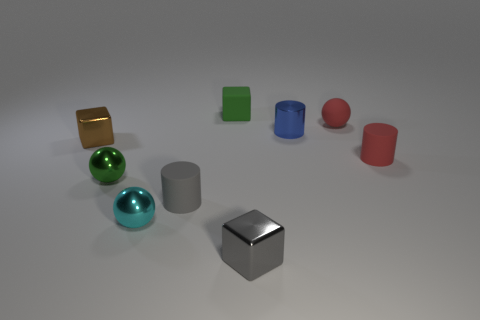Are the objects on the surface placed in a specific pattern or sequence? The objects seem to be arranged randomly on the surface, without any apparent sequence or pattern. 